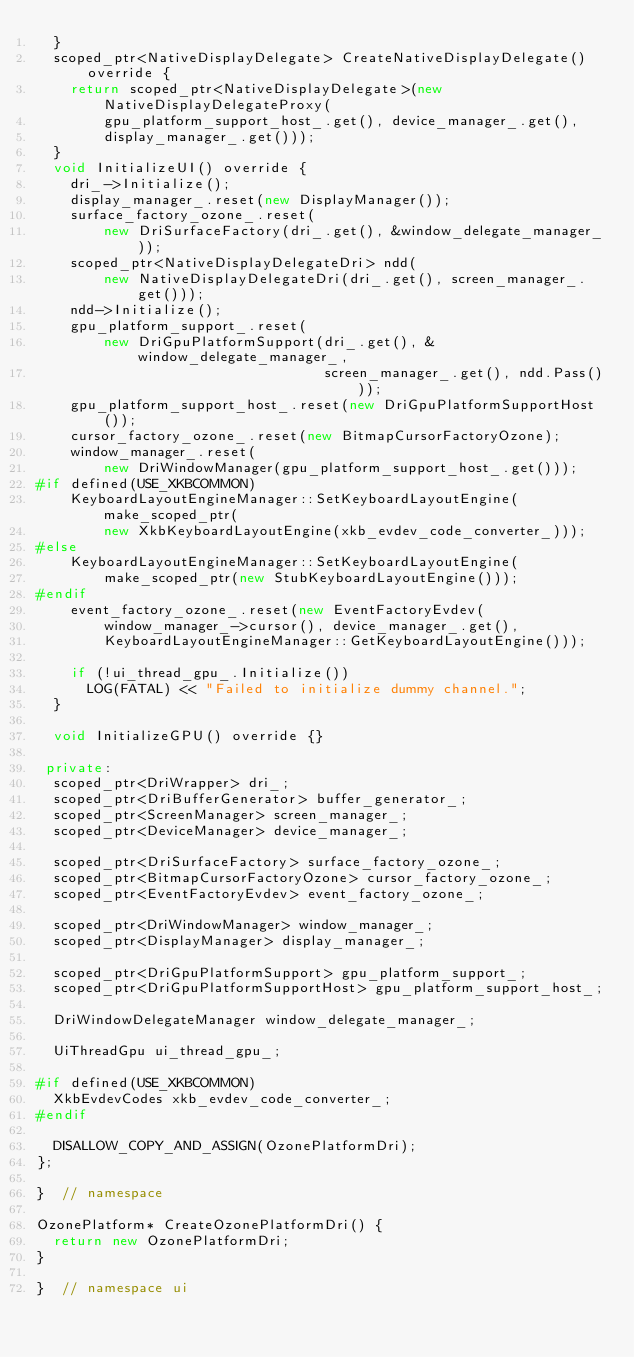<code> <loc_0><loc_0><loc_500><loc_500><_C++_>  }
  scoped_ptr<NativeDisplayDelegate> CreateNativeDisplayDelegate() override {
    return scoped_ptr<NativeDisplayDelegate>(new NativeDisplayDelegateProxy(
        gpu_platform_support_host_.get(), device_manager_.get(),
        display_manager_.get()));
  }
  void InitializeUI() override {
    dri_->Initialize();
    display_manager_.reset(new DisplayManager());
    surface_factory_ozone_.reset(
        new DriSurfaceFactory(dri_.get(), &window_delegate_manager_));
    scoped_ptr<NativeDisplayDelegateDri> ndd(
        new NativeDisplayDelegateDri(dri_.get(), screen_manager_.get()));
    ndd->Initialize();
    gpu_platform_support_.reset(
        new DriGpuPlatformSupport(dri_.get(), &window_delegate_manager_,
                                  screen_manager_.get(), ndd.Pass()));
    gpu_platform_support_host_.reset(new DriGpuPlatformSupportHost());
    cursor_factory_ozone_.reset(new BitmapCursorFactoryOzone);
    window_manager_.reset(
        new DriWindowManager(gpu_platform_support_host_.get()));
#if defined(USE_XKBCOMMON)
    KeyboardLayoutEngineManager::SetKeyboardLayoutEngine(make_scoped_ptr(
        new XkbKeyboardLayoutEngine(xkb_evdev_code_converter_)));
#else
    KeyboardLayoutEngineManager::SetKeyboardLayoutEngine(
        make_scoped_ptr(new StubKeyboardLayoutEngine()));
#endif
    event_factory_ozone_.reset(new EventFactoryEvdev(
        window_manager_->cursor(), device_manager_.get(),
        KeyboardLayoutEngineManager::GetKeyboardLayoutEngine()));

    if (!ui_thread_gpu_.Initialize())
      LOG(FATAL) << "Failed to initialize dummy channel.";
  }

  void InitializeGPU() override {}

 private:
  scoped_ptr<DriWrapper> dri_;
  scoped_ptr<DriBufferGenerator> buffer_generator_;
  scoped_ptr<ScreenManager> screen_manager_;
  scoped_ptr<DeviceManager> device_manager_;

  scoped_ptr<DriSurfaceFactory> surface_factory_ozone_;
  scoped_ptr<BitmapCursorFactoryOzone> cursor_factory_ozone_;
  scoped_ptr<EventFactoryEvdev> event_factory_ozone_;

  scoped_ptr<DriWindowManager> window_manager_;
  scoped_ptr<DisplayManager> display_manager_;

  scoped_ptr<DriGpuPlatformSupport> gpu_platform_support_;
  scoped_ptr<DriGpuPlatformSupportHost> gpu_platform_support_host_;

  DriWindowDelegateManager window_delegate_manager_;

  UiThreadGpu ui_thread_gpu_;

#if defined(USE_XKBCOMMON)
  XkbEvdevCodes xkb_evdev_code_converter_;
#endif

  DISALLOW_COPY_AND_ASSIGN(OzonePlatformDri);
};

}  // namespace

OzonePlatform* CreateOzonePlatformDri() {
  return new OzonePlatformDri;
}

}  // namespace ui
</code> 